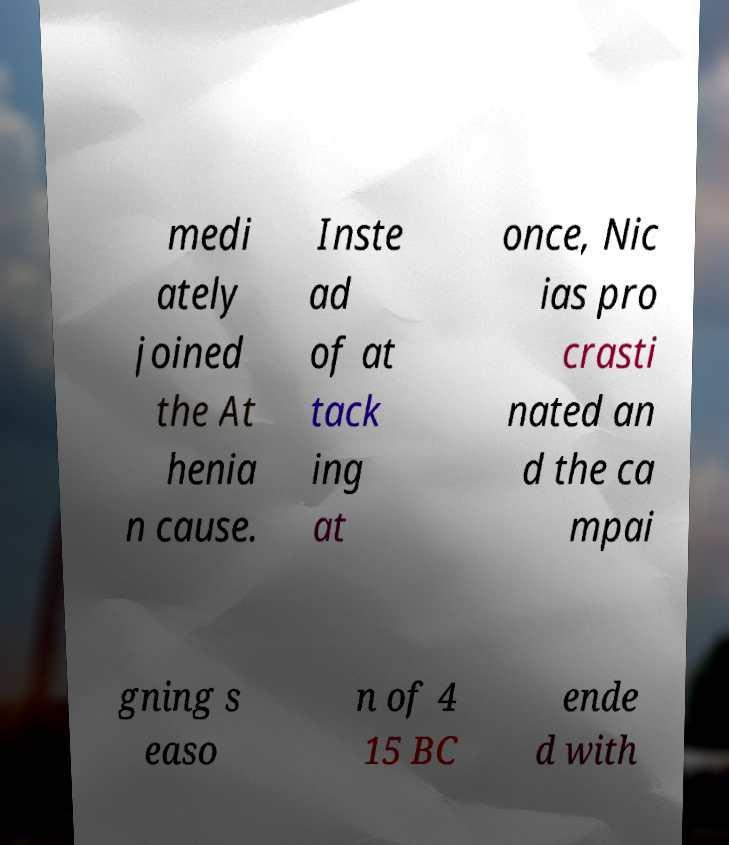Could you assist in decoding the text presented in this image and type it out clearly? medi ately joined the At henia n cause. Inste ad of at tack ing at once, Nic ias pro crasti nated an d the ca mpai gning s easo n of 4 15 BC ende d with 